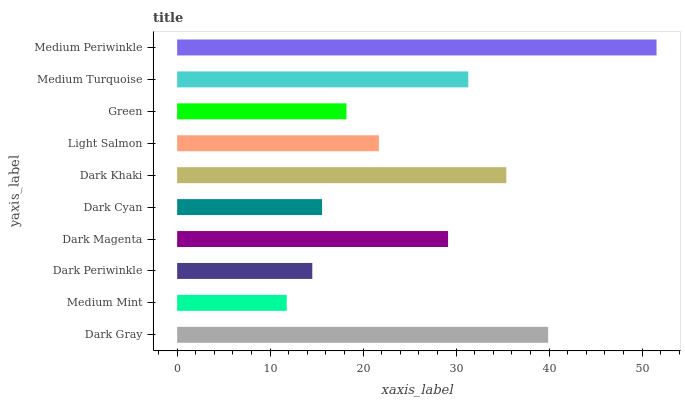Is Medium Mint the minimum?
Answer yes or no. Yes. Is Medium Periwinkle the maximum?
Answer yes or no. Yes. Is Dark Periwinkle the minimum?
Answer yes or no. No. Is Dark Periwinkle the maximum?
Answer yes or no. No. Is Dark Periwinkle greater than Medium Mint?
Answer yes or no. Yes. Is Medium Mint less than Dark Periwinkle?
Answer yes or no. Yes. Is Medium Mint greater than Dark Periwinkle?
Answer yes or no. No. Is Dark Periwinkle less than Medium Mint?
Answer yes or no. No. Is Dark Magenta the high median?
Answer yes or no. Yes. Is Light Salmon the low median?
Answer yes or no. Yes. Is Medium Turquoise the high median?
Answer yes or no. No. Is Medium Mint the low median?
Answer yes or no. No. 